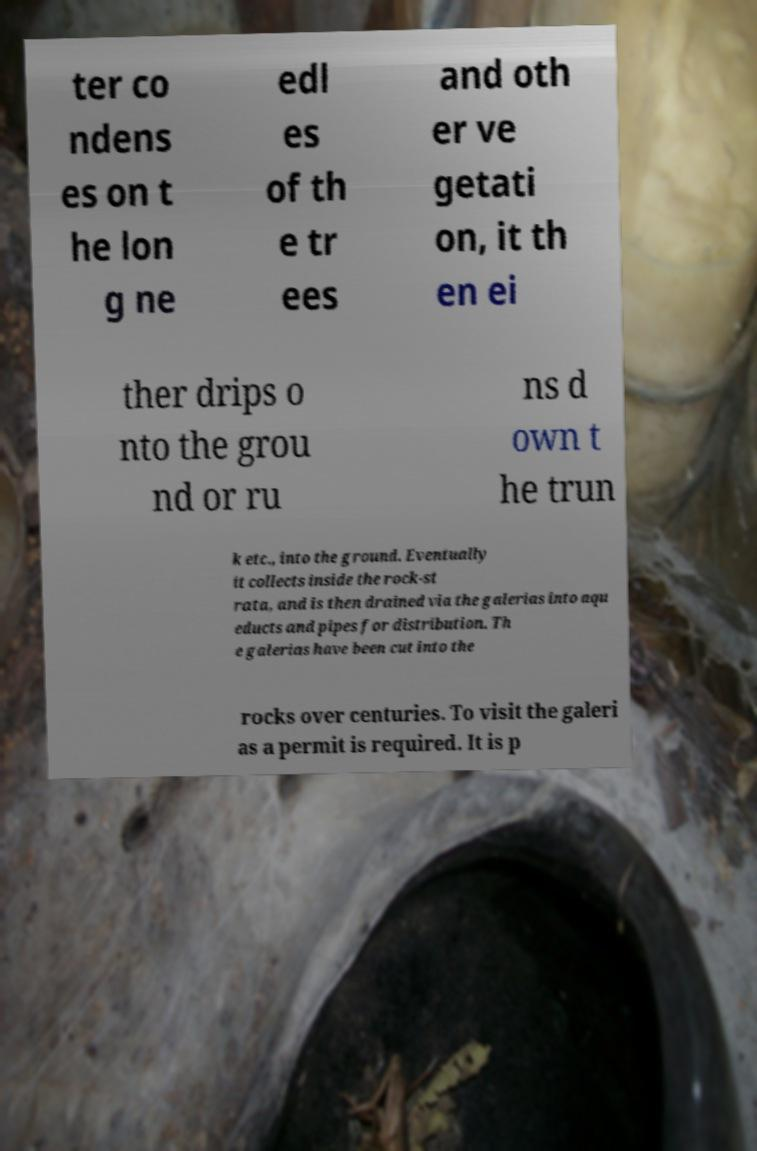Please identify and transcribe the text found in this image. ter co ndens es on t he lon g ne edl es of th e tr ees and oth er ve getati on, it th en ei ther drips o nto the grou nd or ru ns d own t he trun k etc., into the ground. Eventually it collects inside the rock-st rata, and is then drained via the galerias into aqu educts and pipes for distribution. Th e galerias have been cut into the rocks over centuries. To visit the galeri as a permit is required. It is p 